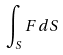<formula> <loc_0><loc_0><loc_500><loc_500>\int _ { S } F d S</formula> 